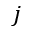Convert formula to latex. <formula><loc_0><loc_0><loc_500><loc_500>j</formula> 